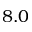Convert formula to latex. <formula><loc_0><loc_0><loc_500><loc_500>8 . 0</formula> 